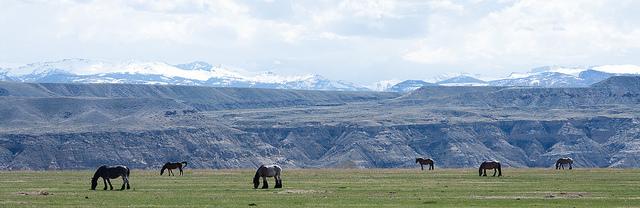Are the horses in motion?
Quick response, please. No. Is it windy here?
Answer briefly. No. Are these race horses?
Be succinct. No. How many horses are in the field?
Answer briefly. 6. 